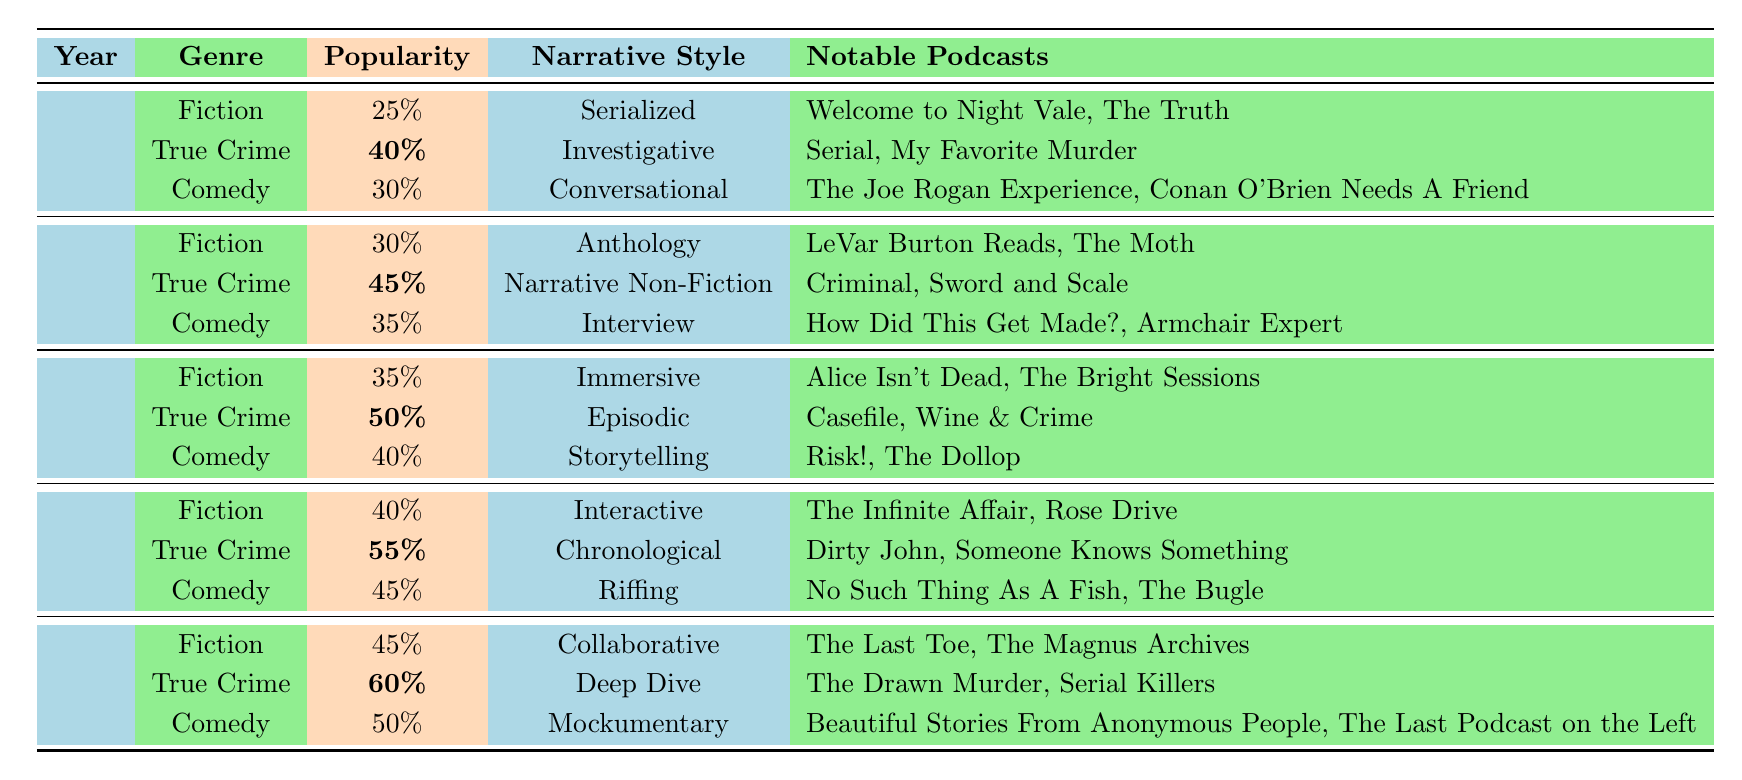What was the highest popularity percentage for the True Crime genre? The True Crime genre had a popularity of 60% in 2023, which is the highest documented in the table over the five years.
Answer: 60% Which year saw the most popular Fiction podcast style and what was that percentage? The Fiction podcast genre peaked in popularity in 2023 with a popularity of 45%.
Answer: 45% What was the average popularity percentage of Comedy podcasts from 2019 to 2023? The popularity percentages for Comedy podcasts are 30%, 35%, 40%, 45%, and 50%. Summing these gives 200%. Dividing by the 5 years (200% / 5) gives an average of 40%.
Answer: 40% Did the popularity of the True Crime genre increase every year from 2019 to 2023? The popularity of True Crime podcasts increased from 40% in 2019 to 45% in 2020, 50% in 2021, 55% in 2022, and 60% in 2023, indicating a continuous increase.
Answer: Yes In 2022, what was the difference in popularity between the True Crime and Comedy genres? True Crime was at 55% popularity and Comedy at 45% in 2022. The difference is 55% - 45% = 10%.
Answer: 10% Which narrative style had the highest popularity in 2023, and how does it compare to previous years? In 2023, the True Crime genre with the narrative style "Deep Dive" had the highest popularity at 60%. This is the highest percentage recorded across all years, indicating a significant interest.
Answer: Deep Dive, 60% is the highest What was the notable percentage increase in Fiction genre popularity from 2019 to 2023? The Fiction genre grew from 25% in 2019 to 45% in 2023. The increase is calculated as 45% - 25% = 20%, showing a substantial growth over the years.
Answer: 20% Which genre had the lowest popularity in the first year, and what was that percentage? In 2019, the Fiction genre had the lowest popularity at 25% compared to True Crime and Comedy.
Answer: Fiction, 25% How many notable podcasts are listed for the Comedy genre in total over the five years? The Comedy genre lists two notable podcasts for each year (2019-2023), totaling 2 podcasts per year times 5 years equals 10 notable podcasts.
Answer: 10 What narrative style was applied to the True Crime genre in 2021 and how does its popularity compare to that of 2019? In 2021, True Crime used the Episodic narrative style with a popularity of 50%. Compared to 2019's 40%, this shows a 10% increase.
Answer: 10% increase Is there a significant transformation in the narrative styles used in Fiction podcasts from 2019 to 2023? Yes, the narrative styles changed from Serialized in 2019 to Collaborative in 2023, indicating an evolution in storytelling techniques.
Answer: Yes 